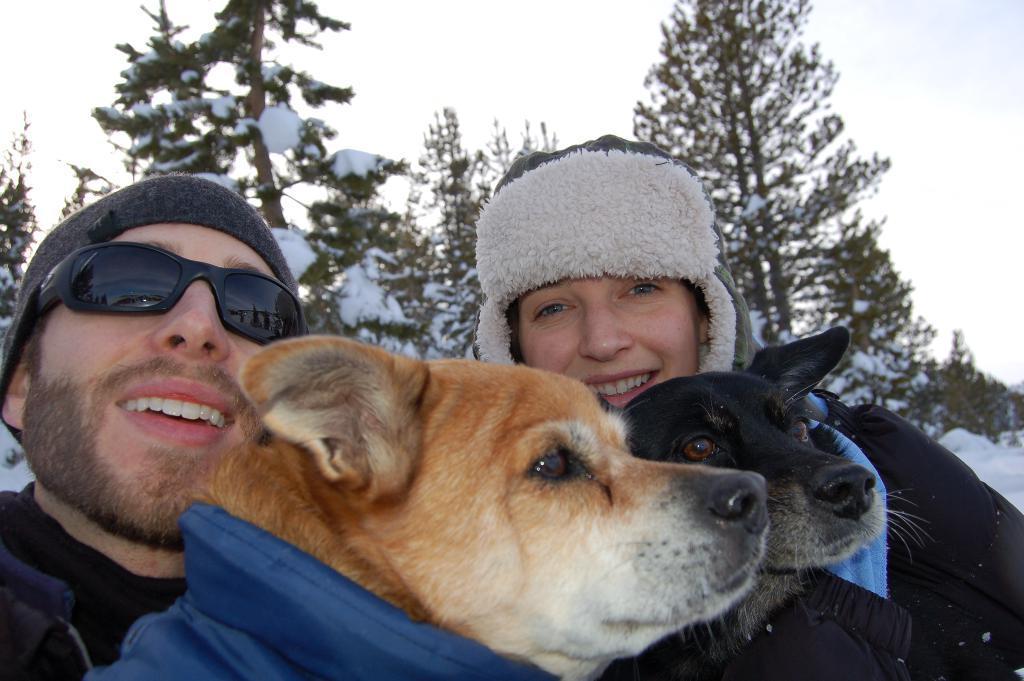Describe this image in one or two sentences. In this picture there is man and woman holding two dogs. There is a black dog and a white brown colour mixed dog. There are trees in the background and snow is on top if it. 